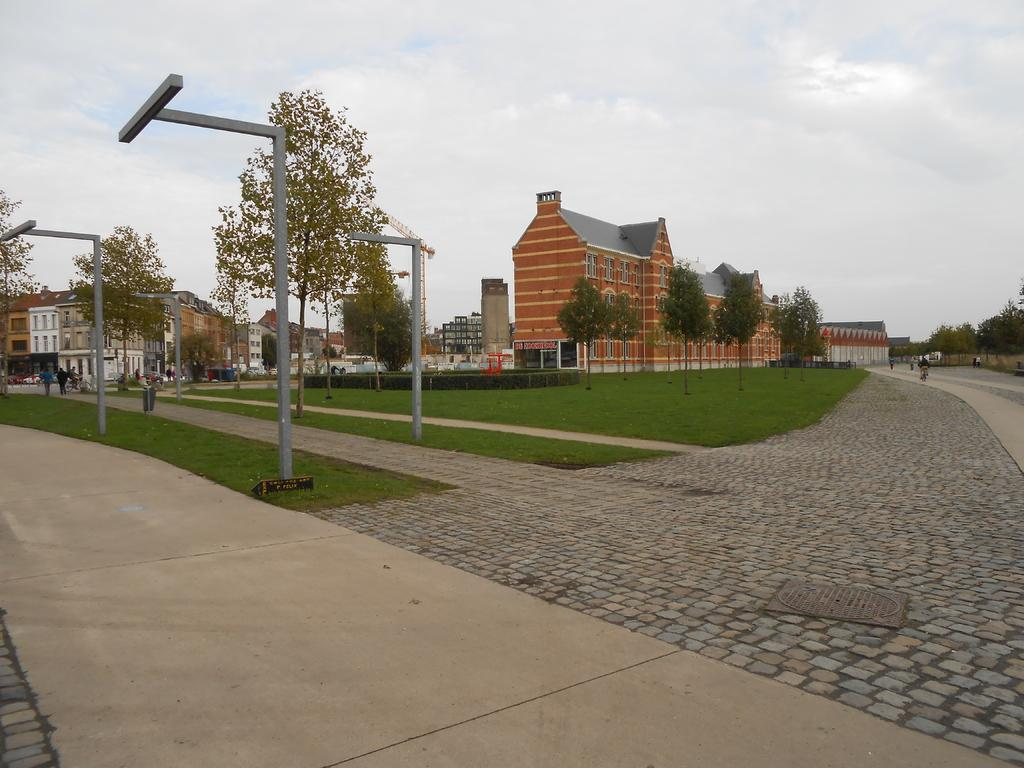What is the main subject of the image? The main subject of the image is the buildings at the center. What can be seen in front of the buildings? Trees are present in front of the buildings. What are the people in the image doing? There are people walking on a path in front of the buildings. What else can be seen in the image besides the buildings and trees? There are poles visible in the image. What is visible in the background of the image? The sky is visible in the background of the image. What type of glue is being used by the trees in the image? There is no glue present in the image; the trees are natural vegetation. What type of apparel are the buildings wearing in the image? Buildings do not wear apparel; they are inanimate structures. 